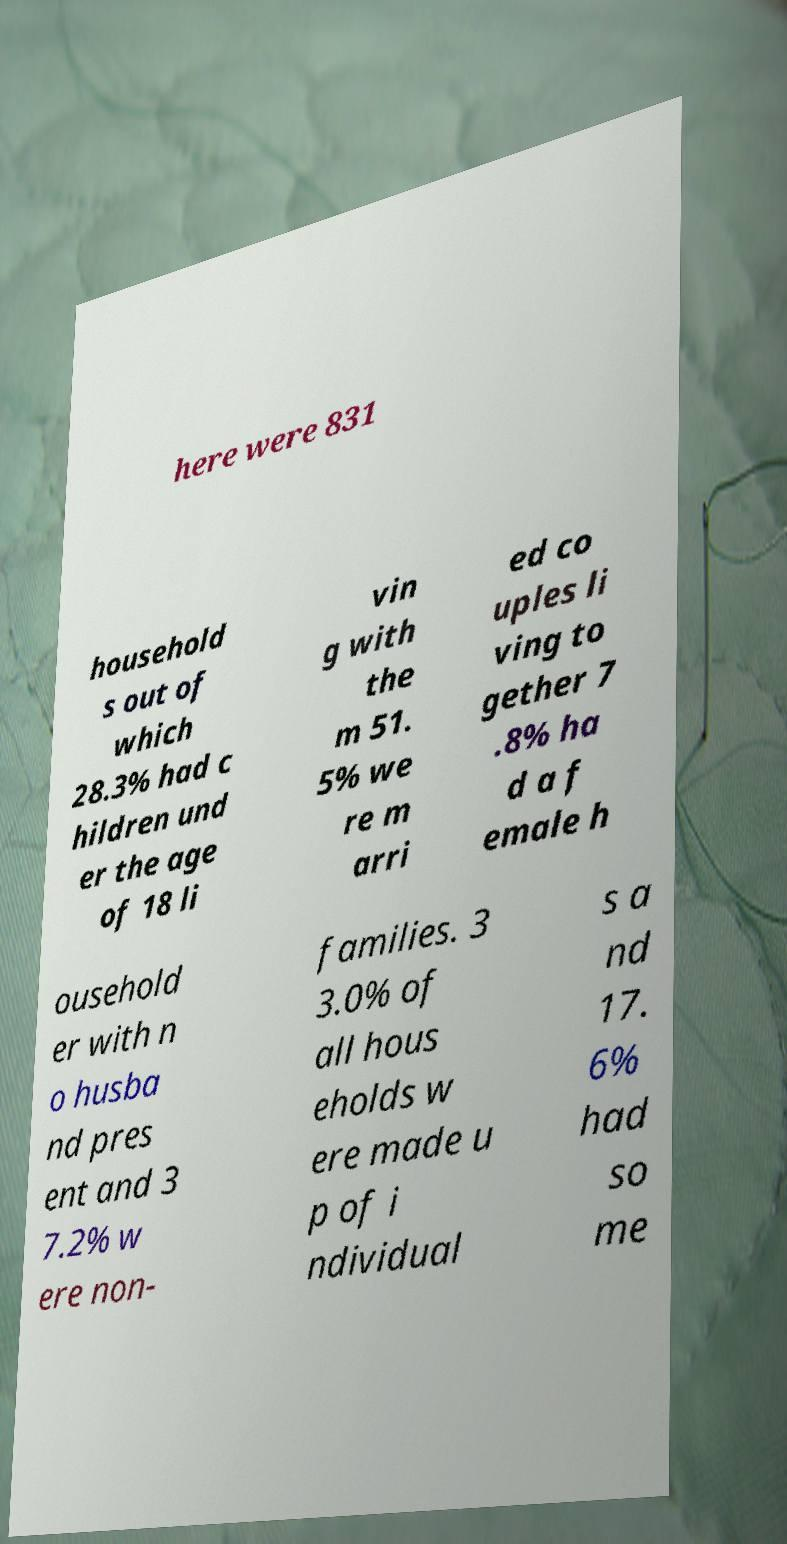For documentation purposes, I need the text within this image transcribed. Could you provide that? here were 831 household s out of which 28.3% had c hildren und er the age of 18 li vin g with the m 51. 5% we re m arri ed co uples li ving to gether 7 .8% ha d a f emale h ousehold er with n o husba nd pres ent and 3 7.2% w ere non- families. 3 3.0% of all hous eholds w ere made u p of i ndividual s a nd 17. 6% had so me 